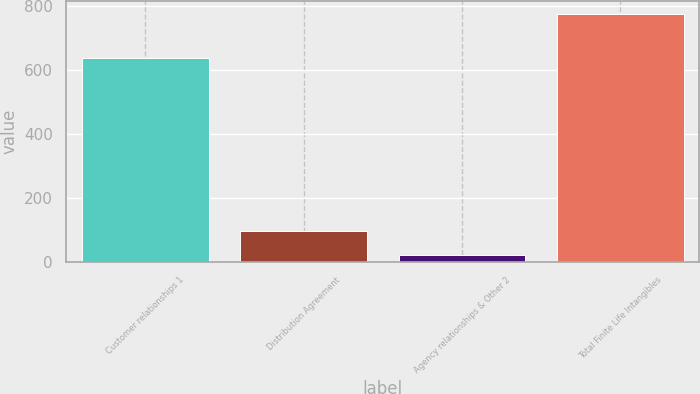Convert chart. <chart><loc_0><loc_0><loc_500><loc_500><bar_chart><fcel>Customer relationships 1<fcel>Distribution Agreement<fcel>Agency relationships & Other 2<fcel>Total Finite Life Intangibles<nl><fcel>636<fcel>96.4<fcel>21<fcel>775<nl></chart> 